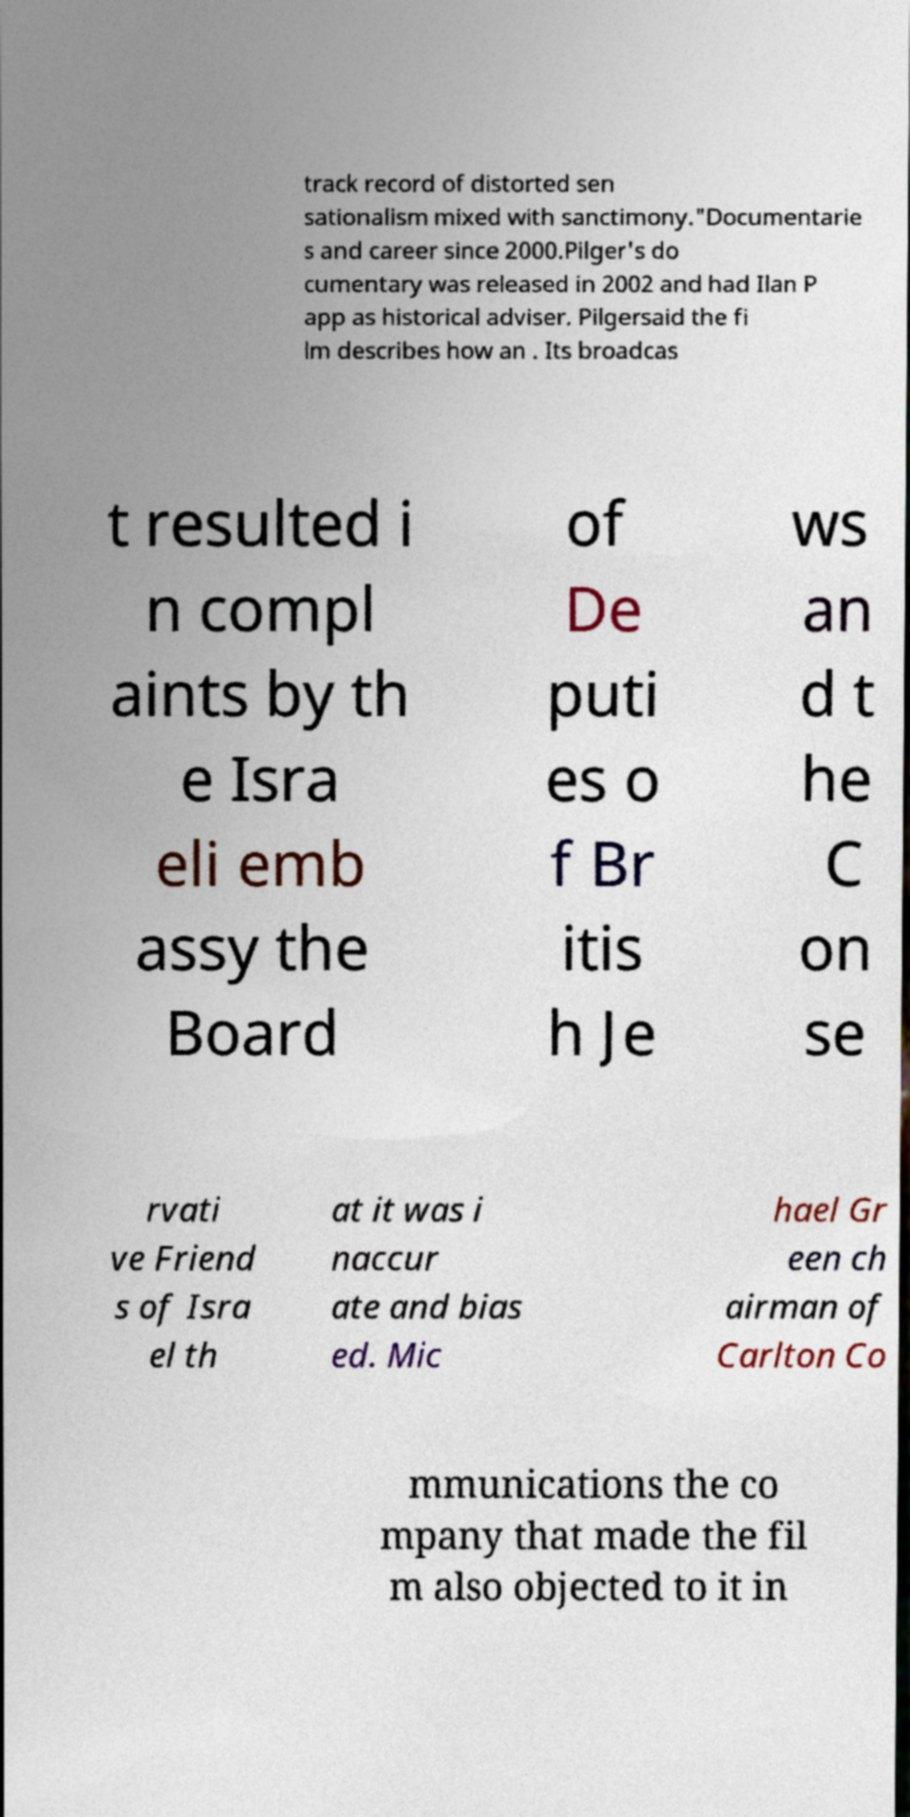There's text embedded in this image that I need extracted. Can you transcribe it verbatim? track record of distorted sen sationalism mixed with sanctimony."Documentarie s and career since 2000.Pilger's do cumentary was released in 2002 and had Ilan P app as historical adviser. Pilgersaid the fi lm describes how an . Its broadcas t resulted i n compl aints by th e Isra eli emb assy the Board of De puti es o f Br itis h Je ws an d t he C on se rvati ve Friend s of Isra el th at it was i naccur ate and bias ed. Mic hael Gr een ch airman of Carlton Co mmunications the co mpany that made the fil m also objected to it in 